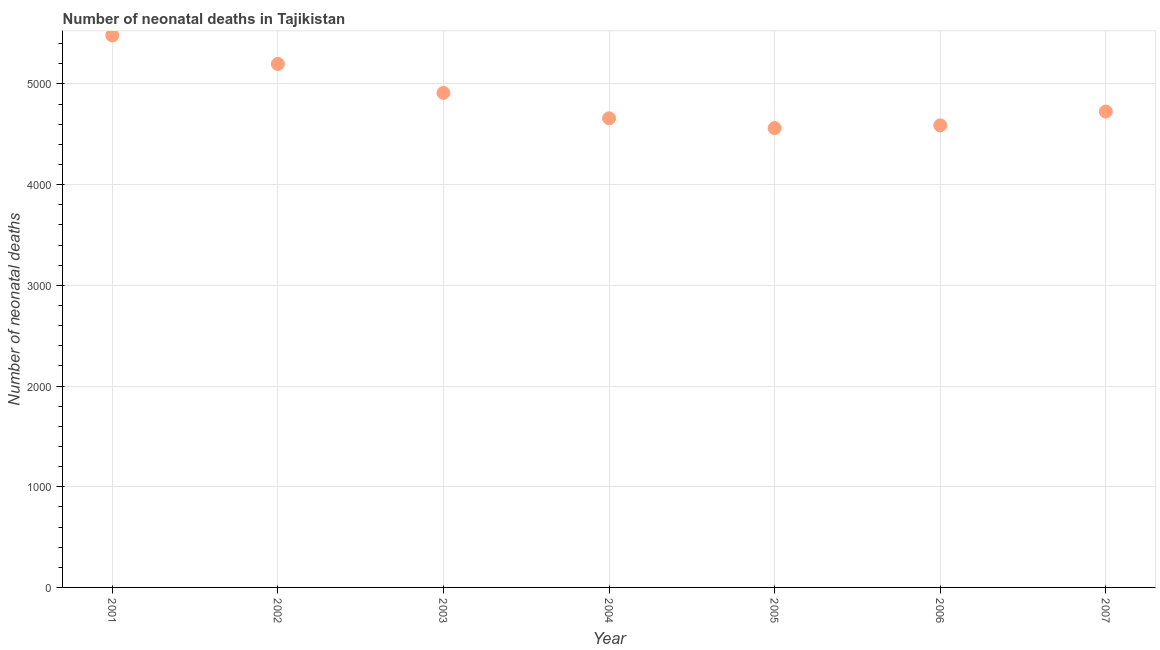What is the number of neonatal deaths in 2007?
Your answer should be compact. 4726. Across all years, what is the maximum number of neonatal deaths?
Provide a short and direct response. 5482. Across all years, what is the minimum number of neonatal deaths?
Offer a very short reply. 4562. In which year was the number of neonatal deaths minimum?
Your answer should be very brief. 2005. What is the sum of the number of neonatal deaths?
Offer a very short reply. 3.41e+04. What is the difference between the number of neonatal deaths in 2001 and 2007?
Provide a short and direct response. 756. What is the average number of neonatal deaths per year?
Make the answer very short. 4875.43. What is the median number of neonatal deaths?
Offer a very short reply. 4726. In how many years, is the number of neonatal deaths greater than 4600 ?
Your answer should be compact. 5. Do a majority of the years between 2007 and 2002 (inclusive) have number of neonatal deaths greater than 2000 ?
Your answer should be very brief. Yes. What is the ratio of the number of neonatal deaths in 2005 to that in 2007?
Keep it short and to the point. 0.97. What is the difference between the highest and the second highest number of neonatal deaths?
Give a very brief answer. 283. Is the sum of the number of neonatal deaths in 2006 and 2007 greater than the maximum number of neonatal deaths across all years?
Your answer should be very brief. Yes. What is the difference between the highest and the lowest number of neonatal deaths?
Offer a very short reply. 920. Does the number of neonatal deaths monotonically increase over the years?
Give a very brief answer. No. How many dotlines are there?
Give a very brief answer. 1. How many years are there in the graph?
Provide a succinct answer. 7. Does the graph contain any zero values?
Provide a succinct answer. No. Does the graph contain grids?
Keep it short and to the point. Yes. What is the title of the graph?
Ensure brevity in your answer.  Number of neonatal deaths in Tajikistan. What is the label or title of the Y-axis?
Provide a short and direct response. Number of neonatal deaths. What is the Number of neonatal deaths in 2001?
Give a very brief answer. 5482. What is the Number of neonatal deaths in 2002?
Make the answer very short. 5199. What is the Number of neonatal deaths in 2003?
Provide a short and direct response. 4911. What is the Number of neonatal deaths in 2004?
Provide a succinct answer. 4659. What is the Number of neonatal deaths in 2005?
Give a very brief answer. 4562. What is the Number of neonatal deaths in 2006?
Ensure brevity in your answer.  4589. What is the Number of neonatal deaths in 2007?
Offer a terse response. 4726. What is the difference between the Number of neonatal deaths in 2001 and 2002?
Make the answer very short. 283. What is the difference between the Number of neonatal deaths in 2001 and 2003?
Offer a terse response. 571. What is the difference between the Number of neonatal deaths in 2001 and 2004?
Your answer should be very brief. 823. What is the difference between the Number of neonatal deaths in 2001 and 2005?
Your answer should be compact. 920. What is the difference between the Number of neonatal deaths in 2001 and 2006?
Provide a short and direct response. 893. What is the difference between the Number of neonatal deaths in 2001 and 2007?
Offer a terse response. 756. What is the difference between the Number of neonatal deaths in 2002 and 2003?
Your answer should be compact. 288. What is the difference between the Number of neonatal deaths in 2002 and 2004?
Provide a short and direct response. 540. What is the difference between the Number of neonatal deaths in 2002 and 2005?
Your answer should be very brief. 637. What is the difference between the Number of neonatal deaths in 2002 and 2006?
Ensure brevity in your answer.  610. What is the difference between the Number of neonatal deaths in 2002 and 2007?
Your answer should be compact. 473. What is the difference between the Number of neonatal deaths in 2003 and 2004?
Ensure brevity in your answer.  252. What is the difference between the Number of neonatal deaths in 2003 and 2005?
Your response must be concise. 349. What is the difference between the Number of neonatal deaths in 2003 and 2006?
Your answer should be very brief. 322. What is the difference between the Number of neonatal deaths in 2003 and 2007?
Your answer should be very brief. 185. What is the difference between the Number of neonatal deaths in 2004 and 2005?
Your response must be concise. 97. What is the difference between the Number of neonatal deaths in 2004 and 2007?
Offer a very short reply. -67. What is the difference between the Number of neonatal deaths in 2005 and 2007?
Give a very brief answer. -164. What is the difference between the Number of neonatal deaths in 2006 and 2007?
Ensure brevity in your answer.  -137. What is the ratio of the Number of neonatal deaths in 2001 to that in 2002?
Keep it short and to the point. 1.05. What is the ratio of the Number of neonatal deaths in 2001 to that in 2003?
Your response must be concise. 1.12. What is the ratio of the Number of neonatal deaths in 2001 to that in 2004?
Offer a very short reply. 1.18. What is the ratio of the Number of neonatal deaths in 2001 to that in 2005?
Make the answer very short. 1.2. What is the ratio of the Number of neonatal deaths in 2001 to that in 2006?
Your answer should be very brief. 1.2. What is the ratio of the Number of neonatal deaths in 2001 to that in 2007?
Your response must be concise. 1.16. What is the ratio of the Number of neonatal deaths in 2002 to that in 2003?
Provide a succinct answer. 1.06. What is the ratio of the Number of neonatal deaths in 2002 to that in 2004?
Your answer should be compact. 1.12. What is the ratio of the Number of neonatal deaths in 2002 to that in 2005?
Give a very brief answer. 1.14. What is the ratio of the Number of neonatal deaths in 2002 to that in 2006?
Ensure brevity in your answer.  1.13. What is the ratio of the Number of neonatal deaths in 2003 to that in 2004?
Provide a short and direct response. 1.05. What is the ratio of the Number of neonatal deaths in 2003 to that in 2005?
Offer a very short reply. 1.08. What is the ratio of the Number of neonatal deaths in 2003 to that in 2006?
Your answer should be very brief. 1.07. What is the ratio of the Number of neonatal deaths in 2003 to that in 2007?
Provide a succinct answer. 1.04. What is the ratio of the Number of neonatal deaths in 2004 to that in 2005?
Your answer should be compact. 1.02. What is the ratio of the Number of neonatal deaths in 2004 to that in 2006?
Your answer should be compact. 1.01. What is the ratio of the Number of neonatal deaths in 2004 to that in 2007?
Keep it short and to the point. 0.99. What is the ratio of the Number of neonatal deaths in 2005 to that in 2007?
Your response must be concise. 0.96. 